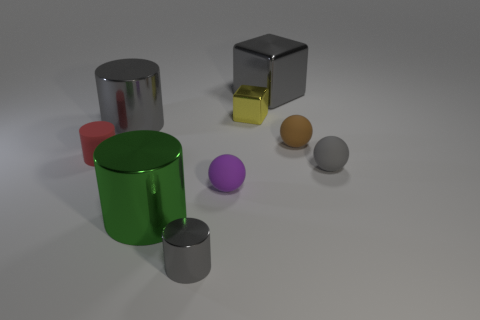Subtract all large gray metal cylinders. How many cylinders are left? 3 Subtract all gray spheres. How many spheres are left? 2 Subtract all spheres. How many objects are left? 6 Subtract 3 spheres. How many spheres are left? 0 Subtract all small gray rubber objects. Subtract all small cylinders. How many objects are left? 6 Add 6 brown rubber things. How many brown rubber things are left? 7 Add 4 brown spheres. How many brown spheres exist? 5 Subtract 0 purple cylinders. How many objects are left? 9 Subtract all green cubes. Subtract all green cylinders. How many cubes are left? 2 Subtract all purple spheres. How many purple cubes are left? 0 